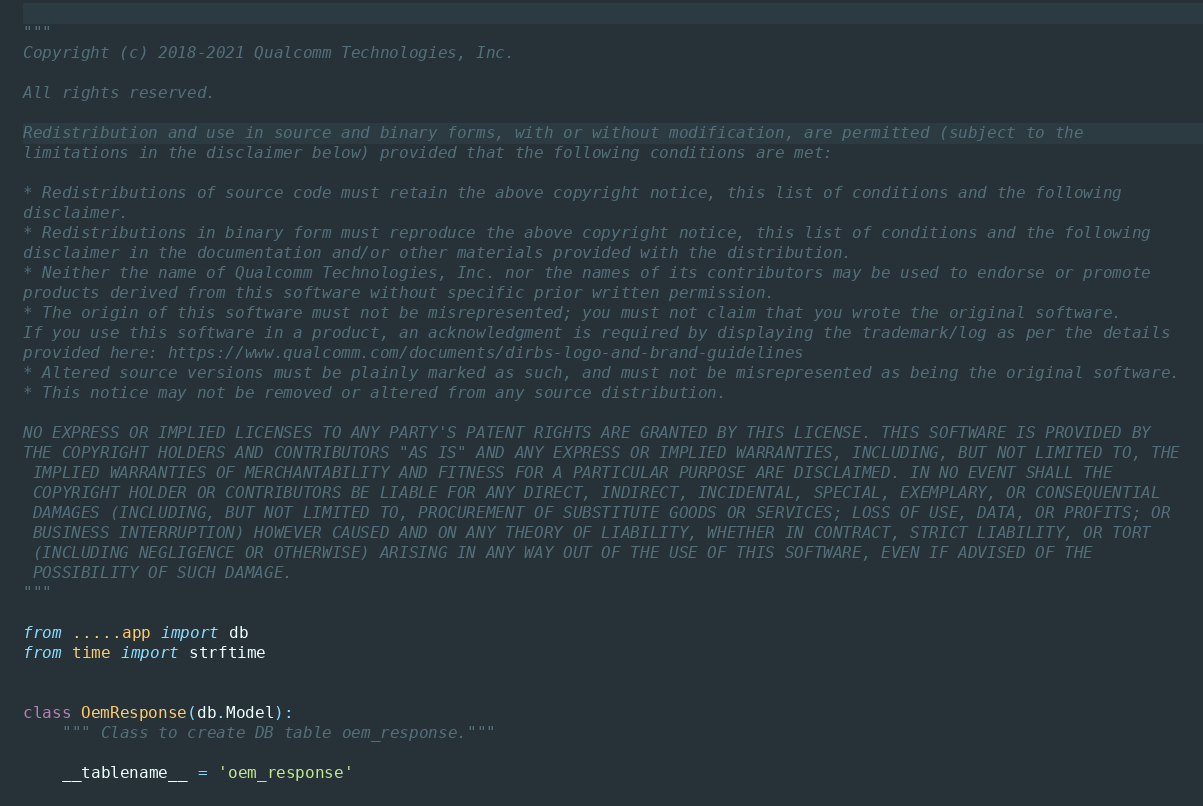Convert code to text. <code><loc_0><loc_0><loc_500><loc_500><_Python_>"""
Copyright (c) 2018-2021 Qualcomm Technologies, Inc.

All rights reserved.

Redistribution and use in source and binary forms, with or without modification, are permitted (subject to the
limitations in the disclaimer below) provided that the following conditions are met:

* Redistributions of source code must retain the above copyright notice, this list of conditions and the following
disclaimer.
* Redistributions in binary form must reproduce the above copyright notice, this list of conditions and the following
disclaimer in the documentation and/or other materials provided with the distribution.
* Neither the name of Qualcomm Technologies, Inc. nor the names of its contributors may be used to endorse or promote
products derived from this software without specific prior written permission.
* The origin of this software must not be misrepresented; you must not claim that you wrote the original software.
If you use this software in a product, an acknowledgment is required by displaying the trademark/log as per the details
provided here: https://www.qualcomm.com/documents/dirbs-logo-and-brand-guidelines
* Altered source versions must be plainly marked as such, and must not be misrepresented as being the original software.
* This notice may not be removed or altered from any source distribution.

NO EXPRESS OR IMPLIED LICENSES TO ANY PARTY'S PATENT RIGHTS ARE GRANTED BY THIS LICENSE. THIS SOFTWARE IS PROVIDED BY
THE COPYRIGHT HOLDERS AND CONTRIBUTORS "AS IS" AND ANY EXPRESS OR IMPLIED WARRANTIES, INCLUDING, BUT NOT LIMITED TO, THE
 IMPLIED WARRANTIES OF MERCHANTABILITY AND FITNESS FOR A PARTICULAR PURPOSE ARE DISCLAIMED. IN NO EVENT SHALL THE
 COPYRIGHT HOLDER OR CONTRIBUTORS BE LIABLE FOR ANY DIRECT, INDIRECT, INCIDENTAL, SPECIAL, EXEMPLARY, OR CONSEQUENTIAL
 DAMAGES (INCLUDING, BUT NOT LIMITED TO, PROCUREMENT OF SUBSTITUTE GOODS OR SERVICES; LOSS OF USE, DATA, OR PROFITS; OR
 BUSINESS INTERRUPTION) HOWEVER CAUSED AND ON ANY THEORY OF LIABILITY, WHETHER IN CONTRACT, STRICT LIABILITY, OR TORT
 (INCLUDING NEGLIGENCE OR OTHERWISE) ARISING IN ANY WAY OUT OF THE USE OF THIS SOFTWARE, EVEN IF ADVISED OF THE
 POSSIBILITY OF SUCH DAMAGE.
"""

from .....app import db
from time import strftime


class OemResponse(db.Model):
    """ Class to create DB table oem_response."""

    __tablename__ = 'oem_response'</code> 